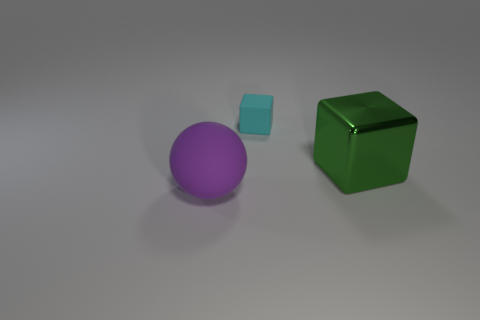Add 2 big yellow balls. How many objects exist? 5 Subtract all cubes. How many objects are left? 1 Subtract all big cyan matte balls. Subtract all purple rubber balls. How many objects are left? 2 Add 3 small matte cubes. How many small matte cubes are left? 4 Add 2 gray matte cylinders. How many gray matte cylinders exist? 2 Subtract 0 blue cubes. How many objects are left? 3 